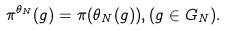<formula> <loc_0><loc_0><loc_500><loc_500>\pi ^ { \theta _ { N } } ( g ) = \pi ( \theta _ { N } ( g ) ) , ( g \in G _ { N } ) .</formula> 